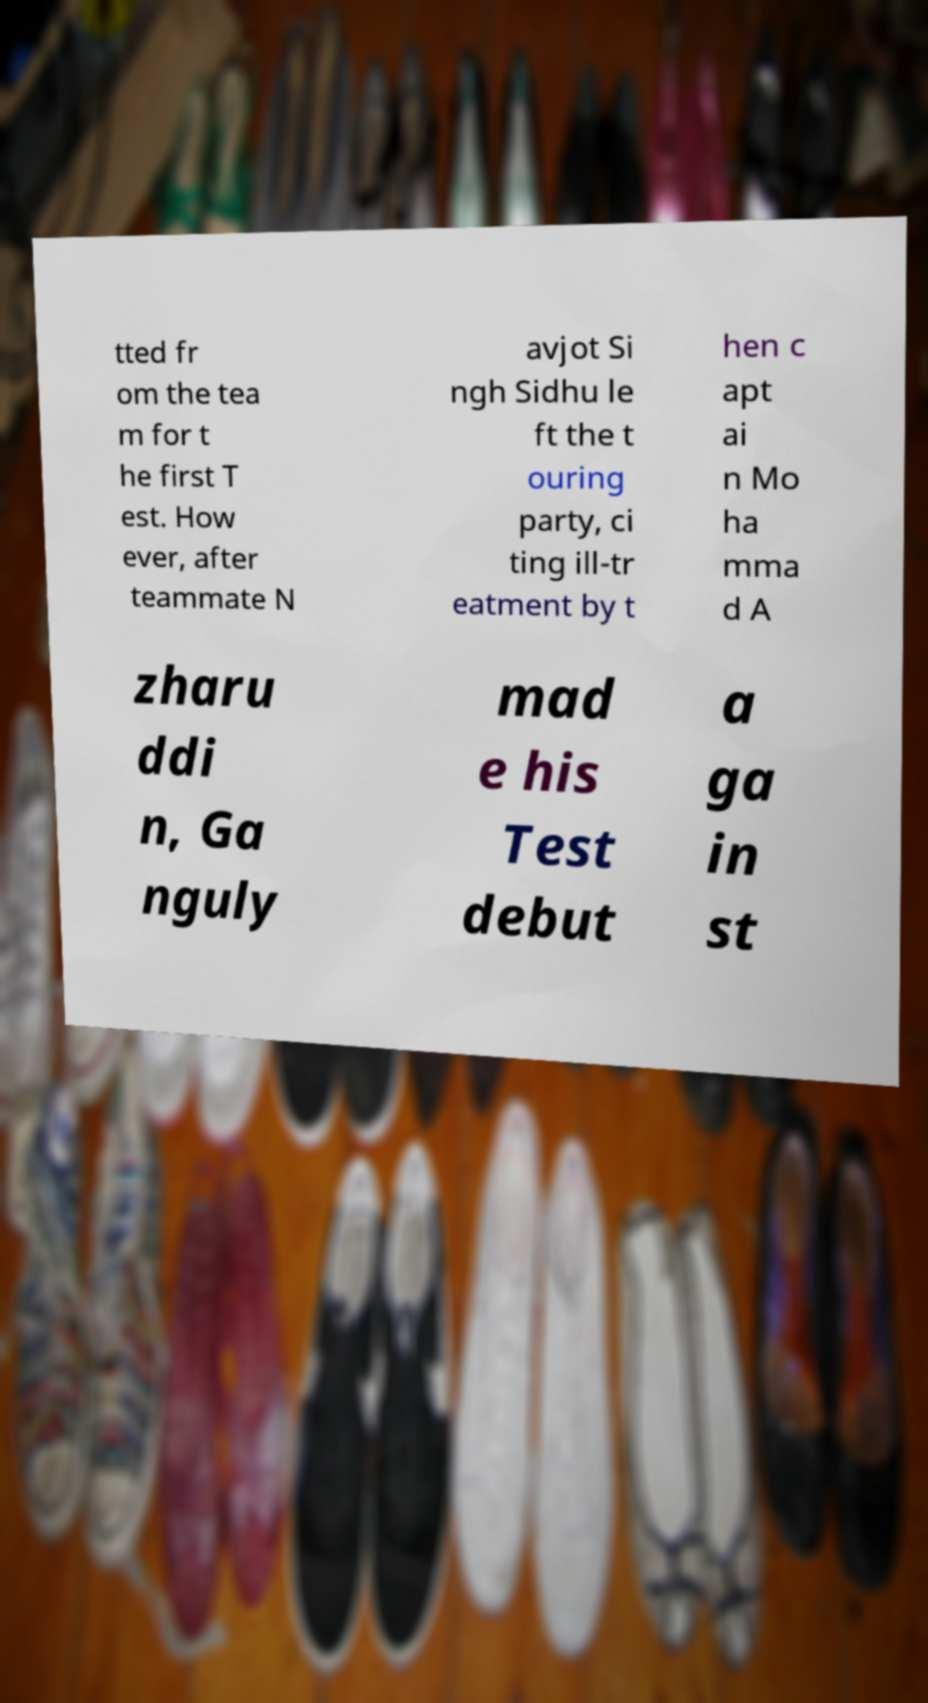Could you extract and type out the text from this image? tted fr om the tea m for t he first T est. How ever, after teammate N avjot Si ngh Sidhu le ft the t ouring party, ci ting ill-tr eatment by t hen c apt ai n Mo ha mma d A zharu ddi n, Ga nguly mad e his Test debut a ga in st 